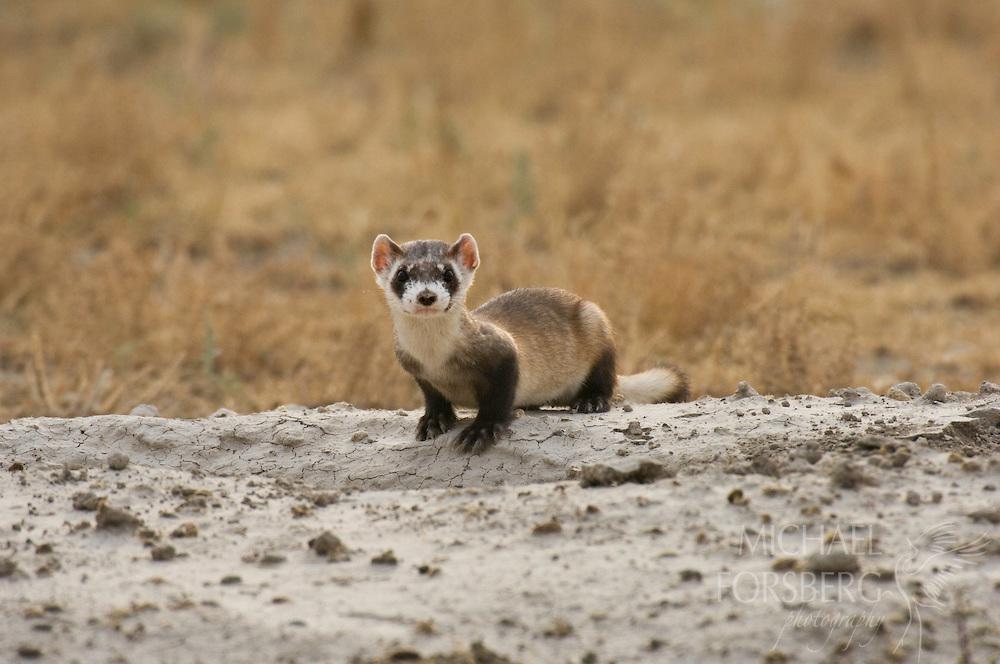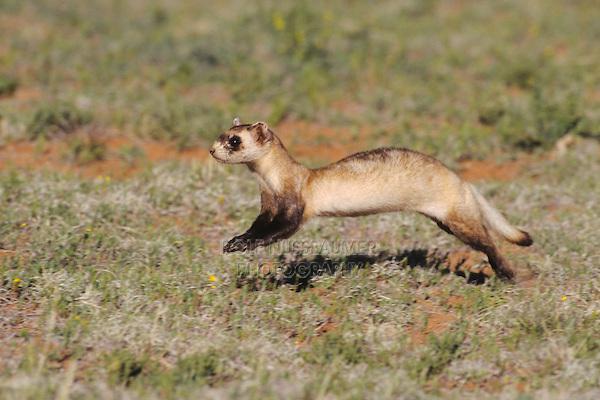The first image is the image on the left, the second image is the image on the right. Analyze the images presented: Is the assertion "The animal in the image on the left is emerging from its burrow." valid? Answer yes or no. No. 